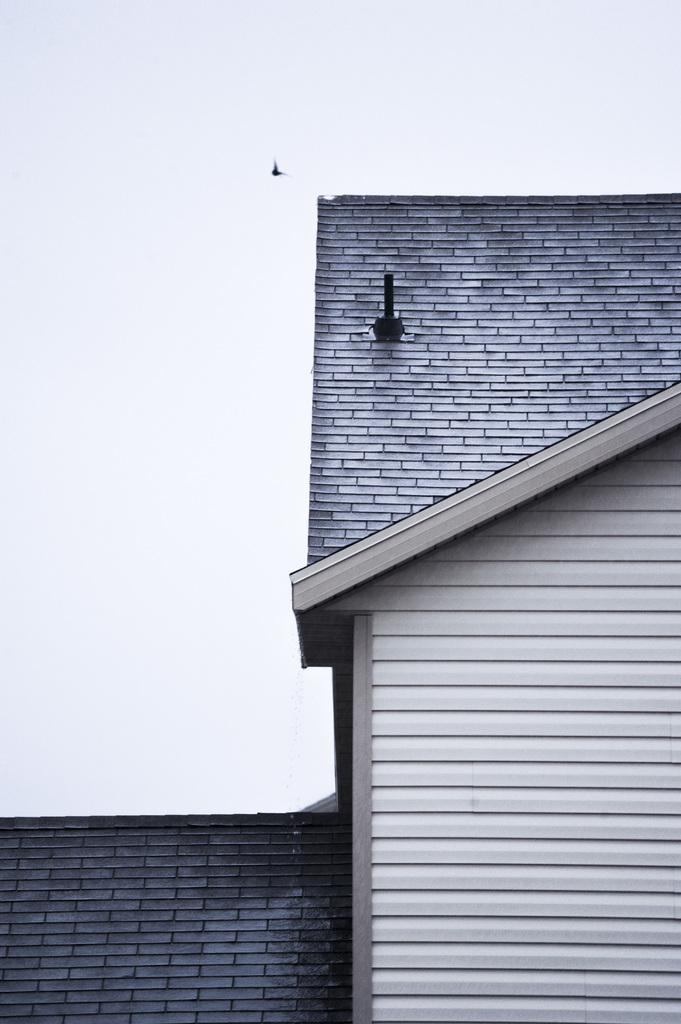What is the main structure visible in the image? There is a building in the picture. How would you describe the sky in the image? The sky appears to be cloudy. Can you identify any living creatures in the image? It looks like a bird is flying in the image. What type of tooth can be seen in the image? There is no tooth present in the image. Can you hear the voice of the bird in the image? The image is silent, so it is not possible to hear the voice of the bird. 